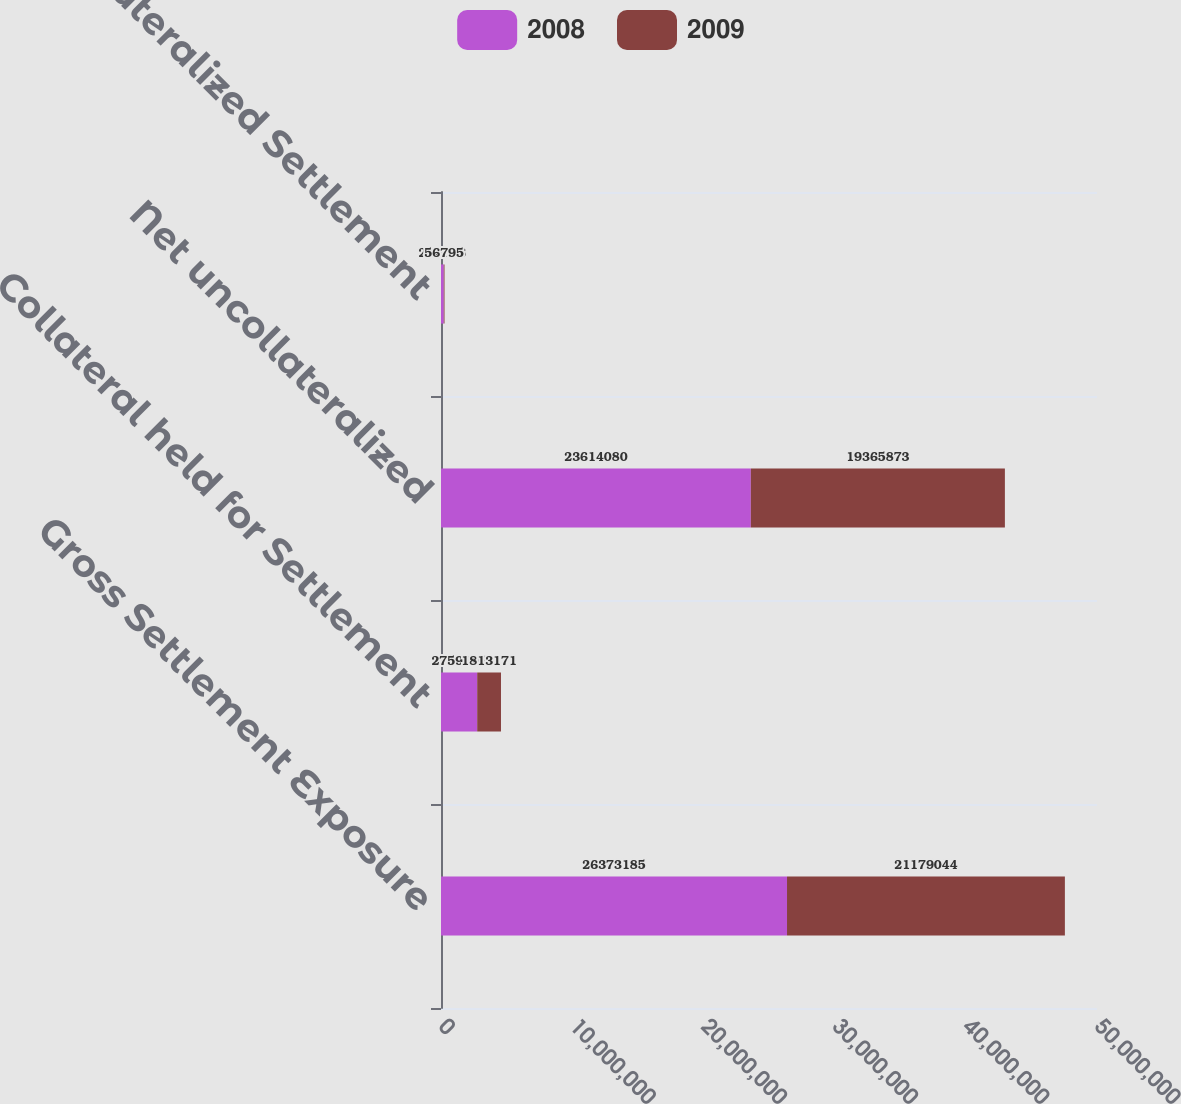<chart> <loc_0><loc_0><loc_500><loc_500><stacked_bar_chart><ecel><fcel>Gross Settlement Exposure<fcel>Collateral held for Settlement<fcel>Net uncollateralized<fcel>Uncollateralized Settlement<nl><fcel>2008<fcel>2.63732e+07<fcel>2.7591e+06<fcel>2.36141e+07<fcel>210618<nl><fcel>2009<fcel>2.1179e+07<fcel>1.81317e+06<fcel>1.93659e+07<fcel>56795<nl></chart> 